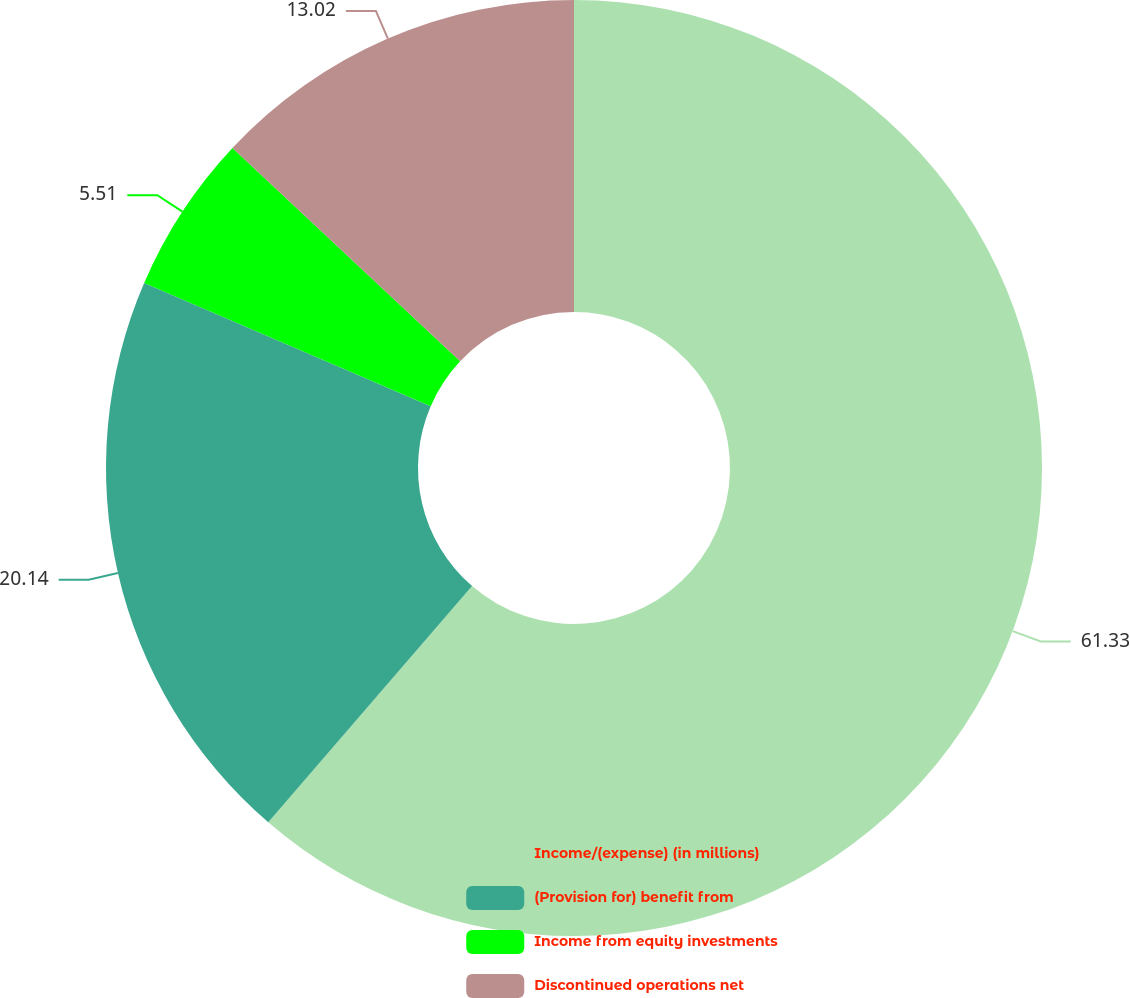<chart> <loc_0><loc_0><loc_500><loc_500><pie_chart><fcel>Income/(expense) (in millions)<fcel>(Provision for) benefit from<fcel>Income from equity investments<fcel>Discontinued operations net<nl><fcel>61.33%<fcel>20.14%<fcel>5.51%<fcel>13.02%<nl></chart> 